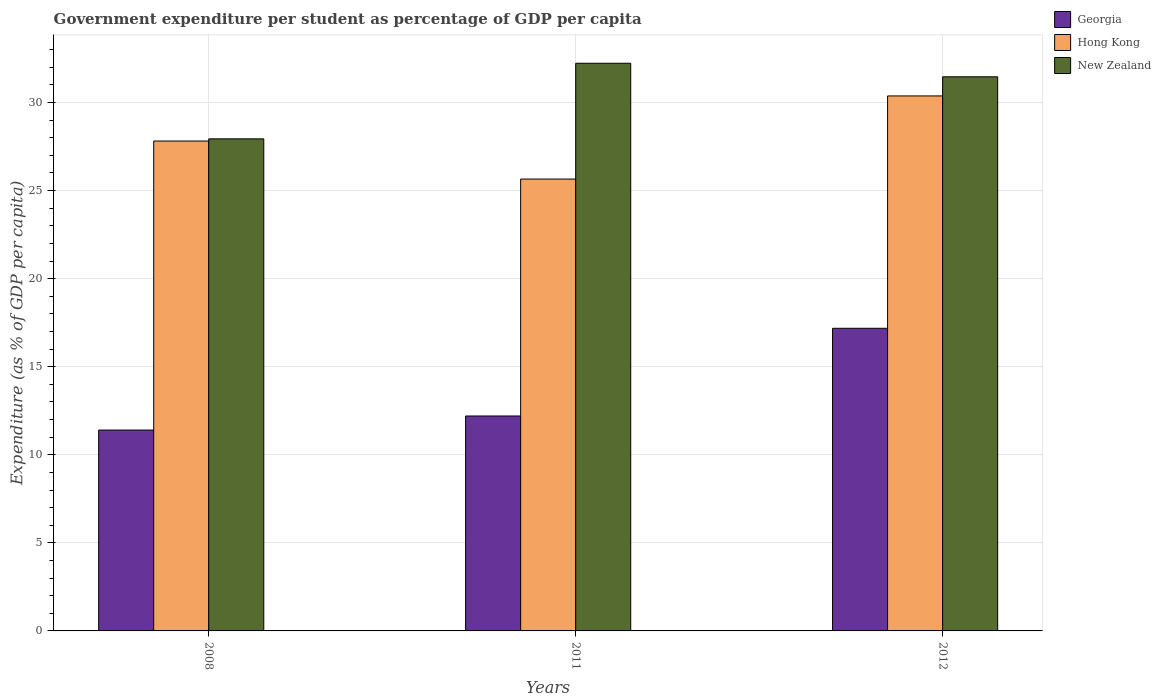How many different coloured bars are there?
Provide a succinct answer. 3. Are the number of bars per tick equal to the number of legend labels?
Your answer should be compact. Yes. What is the percentage of expenditure per student in New Zealand in 2011?
Offer a very short reply. 32.23. Across all years, what is the maximum percentage of expenditure per student in New Zealand?
Make the answer very short. 32.23. Across all years, what is the minimum percentage of expenditure per student in New Zealand?
Offer a terse response. 27.94. In which year was the percentage of expenditure per student in New Zealand minimum?
Give a very brief answer. 2008. What is the total percentage of expenditure per student in Georgia in the graph?
Give a very brief answer. 40.79. What is the difference between the percentage of expenditure per student in Hong Kong in 2008 and that in 2012?
Ensure brevity in your answer.  -2.56. What is the difference between the percentage of expenditure per student in New Zealand in 2008 and the percentage of expenditure per student in Georgia in 2011?
Keep it short and to the point. 15.73. What is the average percentage of expenditure per student in Hong Kong per year?
Keep it short and to the point. 27.95. In the year 2011, what is the difference between the percentage of expenditure per student in New Zealand and percentage of expenditure per student in Hong Kong?
Your answer should be very brief. 6.57. In how many years, is the percentage of expenditure per student in Hong Kong greater than 5 %?
Your answer should be very brief. 3. What is the ratio of the percentage of expenditure per student in New Zealand in 2008 to that in 2011?
Offer a terse response. 0.87. Is the percentage of expenditure per student in New Zealand in 2011 less than that in 2012?
Your answer should be compact. No. Is the difference between the percentage of expenditure per student in New Zealand in 2008 and 2011 greater than the difference between the percentage of expenditure per student in Hong Kong in 2008 and 2011?
Make the answer very short. No. What is the difference between the highest and the second highest percentage of expenditure per student in Georgia?
Make the answer very short. 4.98. What is the difference between the highest and the lowest percentage of expenditure per student in New Zealand?
Ensure brevity in your answer.  4.29. In how many years, is the percentage of expenditure per student in Georgia greater than the average percentage of expenditure per student in Georgia taken over all years?
Your response must be concise. 1. What does the 1st bar from the left in 2011 represents?
Provide a succinct answer. Georgia. What does the 1st bar from the right in 2011 represents?
Provide a succinct answer. New Zealand. Are all the bars in the graph horizontal?
Your response must be concise. No. How many years are there in the graph?
Provide a succinct answer. 3. What is the difference between two consecutive major ticks on the Y-axis?
Your answer should be very brief. 5. Are the values on the major ticks of Y-axis written in scientific E-notation?
Your answer should be very brief. No. How many legend labels are there?
Offer a very short reply. 3. What is the title of the graph?
Your response must be concise. Government expenditure per student as percentage of GDP per capita. What is the label or title of the Y-axis?
Offer a very short reply. Expenditure (as % of GDP per capita). What is the Expenditure (as % of GDP per capita) of Georgia in 2008?
Your response must be concise. 11.4. What is the Expenditure (as % of GDP per capita) of Hong Kong in 2008?
Give a very brief answer. 27.81. What is the Expenditure (as % of GDP per capita) of New Zealand in 2008?
Offer a terse response. 27.94. What is the Expenditure (as % of GDP per capita) of Georgia in 2011?
Make the answer very short. 12.2. What is the Expenditure (as % of GDP per capita) in Hong Kong in 2011?
Your answer should be compact. 25.65. What is the Expenditure (as % of GDP per capita) in New Zealand in 2011?
Offer a terse response. 32.23. What is the Expenditure (as % of GDP per capita) in Georgia in 2012?
Ensure brevity in your answer.  17.18. What is the Expenditure (as % of GDP per capita) in Hong Kong in 2012?
Provide a succinct answer. 30.37. What is the Expenditure (as % of GDP per capita) in New Zealand in 2012?
Your response must be concise. 31.46. Across all years, what is the maximum Expenditure (as % of GDP per capita) in Georgia?
Give a very brief answer. 17.18. Across all years, what is the maximum Expenditure (as % of GDP per capita) in Hong Kong?
Make the answer very short. 30.37. Across all years, what is the maximum Expenditure (as % of GDP per capita) of New Zealand?
Your response must be concise. 32.23. Across all years, what is the minimum Expenditure (as % of GDP per capita) of Georgia?
Your response must be concise. 11.4. Across all years, what is the minimum Expenditure (as % of GDP per capita) of Hong Kong?
Offer a very short reply. 25.65. Across all years, what is the minimum Expenditure (as % of GDP per capita) in New Zealand?
Give a very brief answer. 27.94. What is the total Expenditure (as % of GDP per capita) of Georgia in the graph?
Your response must be concise. 40.79. What is the total Expenditure (as % of GDP per capita) of Hong Kong in the graph?
Give a very brief answer. 83.84. What is the total Expenditure (as % of GDP per capita) of New Zealand in the graph?
Your response must be concise. 91.62. What is the difference between the Expenditure (as % of GDP per capita) in Georgia in 2008 and that in 2011?
Keep it short and to the point. -0.8. What is the difference between the Expenditure (as % of GDP per capita) in Hong Kong in 2008 and that in 2011?
Give a very brief answer. 2.16. What is the difference between the Expenditure (as % of GDP per capita) in New Zealand in 2008 and that in 2011?
Offer a terse response. -4.29. What is the difference between the Expenditure (as % of GDP per capita) of Georgia in 2008 and that in 2012?
Your response must be concise. -5.78. What is the difference between the Expenditure (as % of GDP per capita) of Hong Kong in 2008 and that in 2012?
Your answer should be very brief. -2.56. What is the difference between the Expenditure (as % of GDP per capita) in New Zealand in 2008 and that in 2012?
Your answer should be very brief. -3.52. What is the difference between the Expenditure (as % of GDP per capita) in Georgia in 2011 and that in 2012?
Keep it short and to the point. -4.98. What is the difference between the Expenditure (as % of GDP per capita) in Hong Kong in 2011 and that in 2012?
Your answer should be compact. -4.72. What is the difference between the Expenditure (as % of GDP per capita) in New Zealand in 2011 and that in 2012?
Give a very brief answer. 0.77. What is the difference between the Expenditure (as % of GDP per capita) of Georgia in 2008 and the Expenditure (as % of GDP per capita) of Hong Kong in 2011?
Give a very brief answer. -14.25. What is the difference between the Expenditure (as % of GDP per capita) of Georgia in 2008 and the Expenditure (as % of GDP per capita) of New Zealand in 2011?
Your answer should be very brief. -20.82. What is the difference between the Expenditure (as % of GDP per capita) in Hong Kong in 2008 and the Expenditure (as % of GDP per capita) in New Zealand in 2011?
Provide a succinct answer. -4.42. What is the difference between the Expenditure (as % of GDP per capita) of Georgia in 2008 and the Expenditure (as % of GDP per capita) of Hong Kong in 2012?
Your answer should be compact. -18.97. What is the difference between the Expenditure (as % of GDP per capita) of Georgia in 2008 and the Expenditure (as % of GDP per capita) of New Zealand in 2012?
Make the answer very short. -20.06. What is the difference between the Expenditure (as % of GDP per capita) in Hong Kong in 2008 and the Expenditure (as % of GDP per capita) in New Zealand in 2012?
Ensure brevity in your answer.  -3.65. What is the difference between the Expenditure (as % of GDP per capita) in Georgia in 2011 and the Expenditure (as % of GDP per capita) in Hong Kong in 2012?
Make the answer very short. -18.17. What is the difference between the Expenditure (as % of GDP per capita) in Georgia in 2011 and the Expenditure (as % of GDP per capita) in New Zealand in 2012?
Your response must be concise. -19.26. What is the difference between the Expenditure (as % of GDP per capita) of Hong Kong in 2011 and the Expenditure (as % of GDP per capita) of New Zealand in 2012?
Provide a short and direct response. -5.81. What is the average Expenditure (as % of GDP per capita) in Georgia per year?
Your answer should be compact. 13.6. What is the average Expenditure (as % of GDP per capita) of Hong Kong per year?
Make the answer very short. 27.95. What is the average Expenditure (as % of GDP per capita) of New Zealand per year?
Provide a succinct answer. 30.54. In the year 2008, what is the difference between the Expenditure (as % of GDP per capita) in Georgia and Expenditure (as % of GDP per capita) in Hong Kong?
Ensure brevity in your answer.  -16.41. In the year 2008, what is the difference between the Expenditure (as % of GDP per capita) in Georgia and Expenditure (as % of GDP per capita) in New Zealand?
Keep it short and to the point. -16.53. In the year 2008, what is the difference between the Expenditure (as % of GDP per capita) of Hong Kong and Expenditure (as % of GDP per capita) of New Zealand?
Offer a very short reply. -0.12. In the year 2011, what is the difference between the Expenditure (as % of GDP per capita) of Georgia and Expenditure (as % of GDP per capita) of Hong Kong?
Give a very brief answer. -13.45. In the year 2011, what is the difference between the Expenditure (as % of GDP per capita) in Georgia and Expenditure (as % of GDP per capita) in New Zealand?
Ensure brevity in your answer.  -20.03. In the year 2011, what is the difference between the Expenditure (as % of GDP per capita) in Hong Kong and Expenditure (as % of GDP per capita) in New Zealand?
Provide a short and direct response. -6.57. In the year 2012, what is the difference between the Expenditure (as % of GDP per capita) of Georgia and Expenditure (as % of GDP per capita) of Hong Kong?
Make the answer very short. -13.19. In the year 2012, what is the difference between the Expenditure (as % of GDP per capita) of Georgia and Expenditure (as % of GDP per capita) of New Zealand?
Provide a short and direct response. -14.28. In the year 2012, what is the difference between the Expenditure (as % of GDP per capita) of Hong Kong and Expenditure (as % of GDP per capita) of New Zealand?
Keep it short and to the point. -1.09. What is the ratio of the Expenditure (as % of GDP per capita) in Georgia in 2008 to that in 2011?
Provide a short and direct response. 0.93. What is the ratio of the Expenditure (as % of GDP per capita) of Hong Kong in 2008 to that in 2011?
Provide a short and direct response. 1.08. What is the ratio of the Expenditure (as % of GDP per capita) of New Zealand in 2008 to that in 2011?
Offer a very short reply. 0.87. What is the ratio of the Expenditure (as % of GDP per capita) in Georgia in 2008 to that in 2012?
Offer a very short reply. 0.66. What is the ratio of the Expenditure (as % of GDP per capita) of Hong Kong in 2008 to that in 2012?
Offer a very short reply. 0.92. What is the ratio of the Expenditure (as % of GDP per capita) in New Zealand in 2008 to that in 2012?
Keep it short and to the point. 0.89. What is the ratio of the Expenditure (as % of GDP per capita) in Georgia in 2011 to that in 2012?
Make the answer very short. 0.71. What is the ratio of the Expenditure (as % of GDP per capita) in Hong Kong in 2011 to that in 2012?
Your answer should be compact. 0.84. What is the ratio of the Expenditure (as % of GDP per capita) in New Zealand in 2011 to that in 2012?
Make the answer very short. 1.02. What is the difference between the highest and the second highest Expenditure (as % of GDP per capita) in Georgia?
Your response must be concise. 4.98. What is the difference between the highest and the second highest Expenditure (as % of GDP per capita) of Hong Kong?
Your answer should be compact. 2.56. What is the difference between the highest and the second highest Expenditure (as % of GDP per capita) of New Zealand?
Give a very brief answer. 0.77. What is the difference between the highest and the lowest Expenditure (as % of GDP per capita) in Georgia?
Provide a succinct answer. 5.78. What is the difference between the highest and the lowest Expenditure (as % of GDP per capita) in Hong Kong?
Ensure brevity in your answer.  4.72. What is the difference between the highest and the lowest Expenditure (as % of GDP per capita) of New Zealand?
Ensure brevity in your answer.  4.29. 